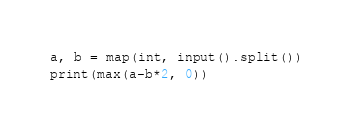<code> <loc_0><loc_0><loc_500><loc_500><_Python_>
a, b = map(int, input().split())
print(max(a-b*2, 0))</code> 